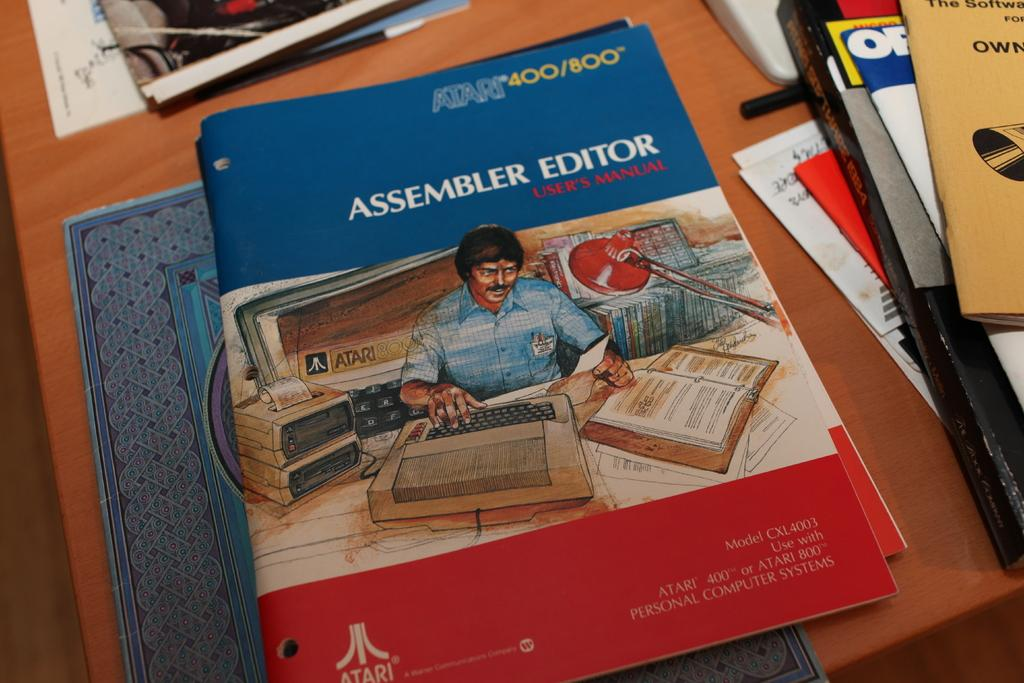What objects are on the table in the image? There are books and papers on the table in the image. What might the books and papers be used for? The books and papers might be used for studying, reading, or writing. What type of cook is visible in the image? There is no cook present in the image. 